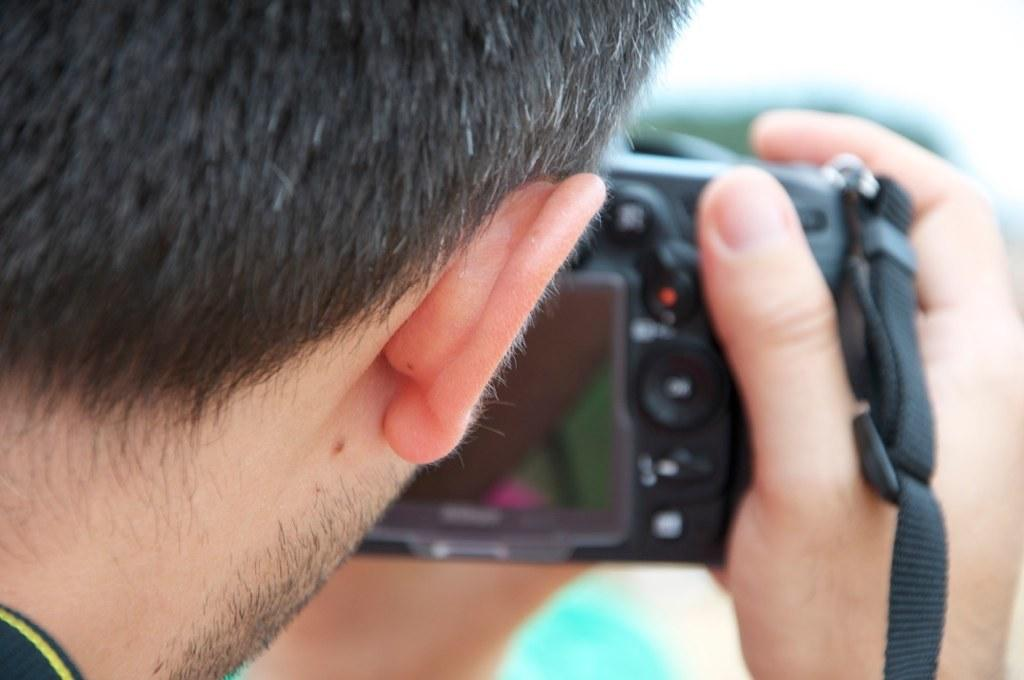Who is the main subject in the image? There is a man in the image. What is the man doing in the image? The man is clicking a picture. What object is the man holding in his hands? The man is holding a camera in his hands. What type of butter is being used to increase the camera's zoom in the image? There is no butter or zoom adjustment present in the image; the man is simply holding a camera and clicking a picture. 